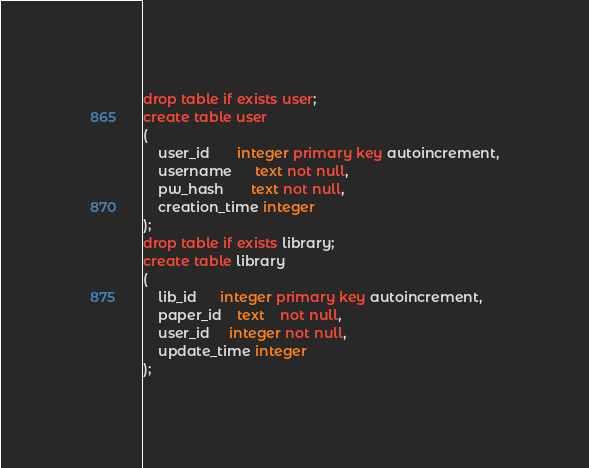<code> <loc_0><loc_0><loc_500><loc_500><_SQL_>drop table if exists user;
create table user
(
    user_id       integer primary key autoincrement,
    username      text not null,
    pw_hash       text not null,
    creation_time integer
);
drop table if exists library;
create table library
(
    lib_id      integer primary key autoincrement,
    paper_id    text    not null,
    user_id     integer not null,
    update_time integer
);
</code> 